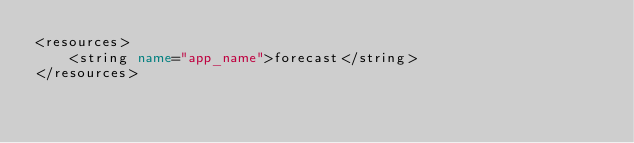<code> <loc_0><loc_0><loc_500><loc_500><_XML_><resources>
    <string name="app_name">forecast</string>
</resources>
</code> 